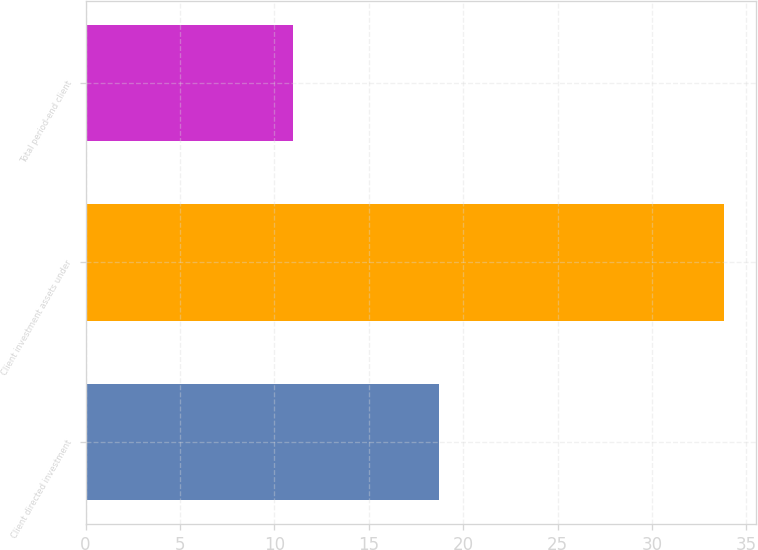<chart> <loc_0><loc_0><loc_500><loc_500><bar_chart><fcel>Client directed investment<fcel>Client investment assets under<fcel>Total period-end client<nl><fcel>18.7<fcel>33.8<fcel>11<nl></chart> 